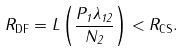Convert formula to latex. <formula><loc_0><loc_0><loc_500><loc_500>R _ { \text {DF} } = L \left ( \frac { P _ { 1 } \lambda _ { 1 2 } } { N _ { 2 } } \right ) < R _ { \text {CS} } .</formula> 